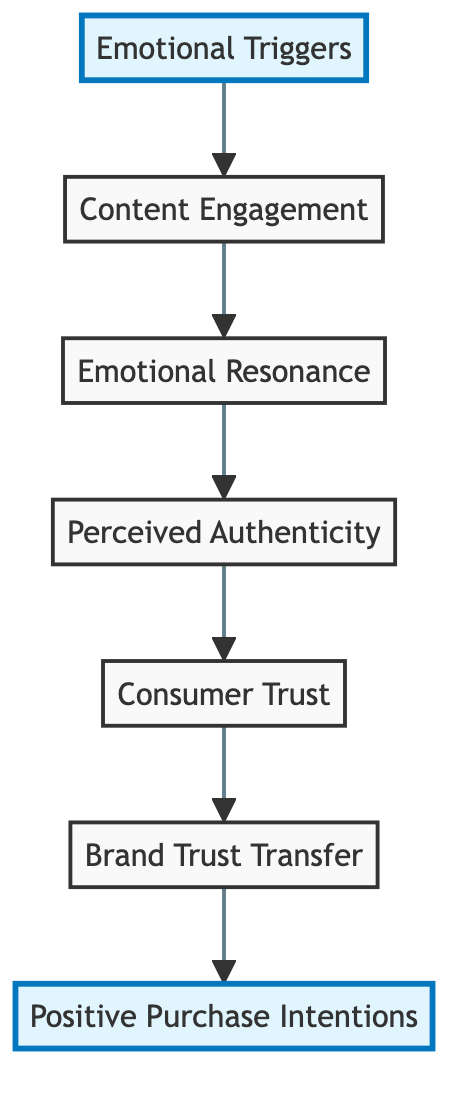What is the first node in the flow chart? The first node in the chart represents the starting point of the flow, which is "Emotional Triggers."
Answer: Emotional Triggers How many levels or nodes are present in the flow chart? The diagram includes a total of seven levels or nodes, each representing a different aspect of the process.
Answer: Seven What is the last node in the flow chart? The last node at the top of the chart corresponds to the final outcome of the process, which is "Positive Purchase Intentions."
Answer: Positive Purchase Intentions What is the relationship between "Perceived Authenticity" and "Consumer Trust"? The relationship indicates that "Perceived Authenticity" leads to the next step, which is "Consumer Trust," demonstrating a direct connection in the process.
Answer: Leads to Which node emphasizes emotional connection through storytelling? The node that highlights the importance of emotional connection through authentic storytelling is "Emotional Resonance."
Answer: Emotional Resonance Explain how "Brand Trust Transfer" is influenced by "Consumer Trust." As "Consumer Trust" builds based on emotional resonance and authenticity, it leads to "Brand Trust Transfer," where the consumer's trust in the influencer is applied to the endorsed brand.
Answer: Influenced by What is indicated by the flow from "Emotional Triggers" to "Content Engagement"? The flow indicates that the initial emotional triggers used by influencers result in the consumer engaging with the content, showing their interest.
Answer: Engagement What role does "Content Engagement" play in the overall process? "Content Engagement" acts as a bridge that connects the emotional triggers to the emotional resonance, marking the transition from interest to deeper personal connections.
Answer: Bridge 